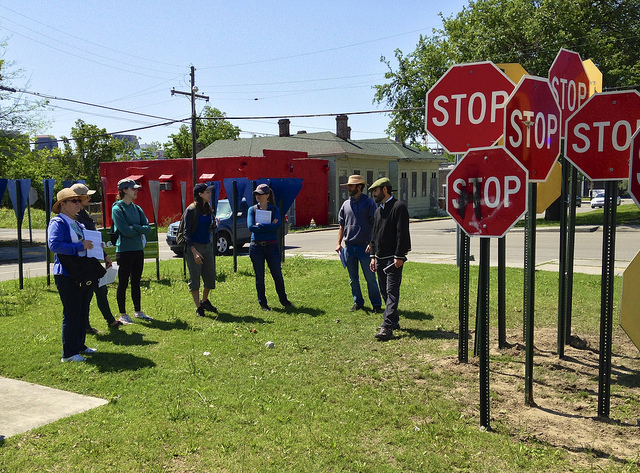Please transcribe the text information in this image. STOP STOP STOP STOP STOP 